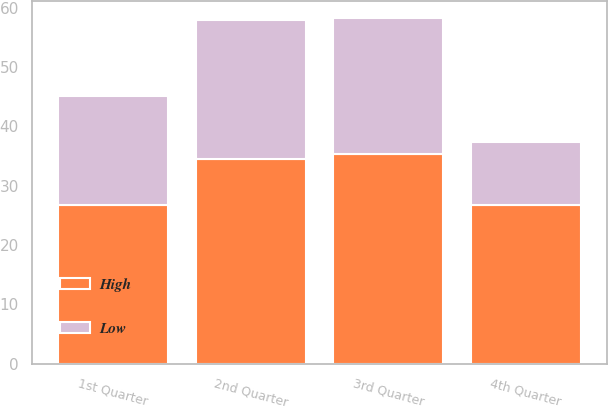<chart> <loc_0><loc_0><loc_500><loc_500><stacked_bar_chart><ecel><fcel>1st Quarter<fcel>2nd Quarter<fcel>3rd Quarter<fcel>4th Quarter<nl><fcel>High<fcel>26.77<fcel>34.51<fcel>35.39<fcel>26.72<nl><fcel>Low<fcel>18.38<fcel>23.4<fcel>22.81<fcel>10.56<nl></chart> 